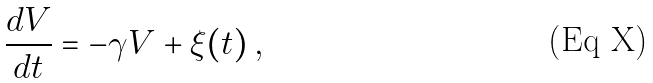Convert formula to latex. <formula><loc_0><loc_0><loc_500><loc_500>\frac { d V } { d t } = - \gamma V + \xi ( t ) \, ,</formula> 